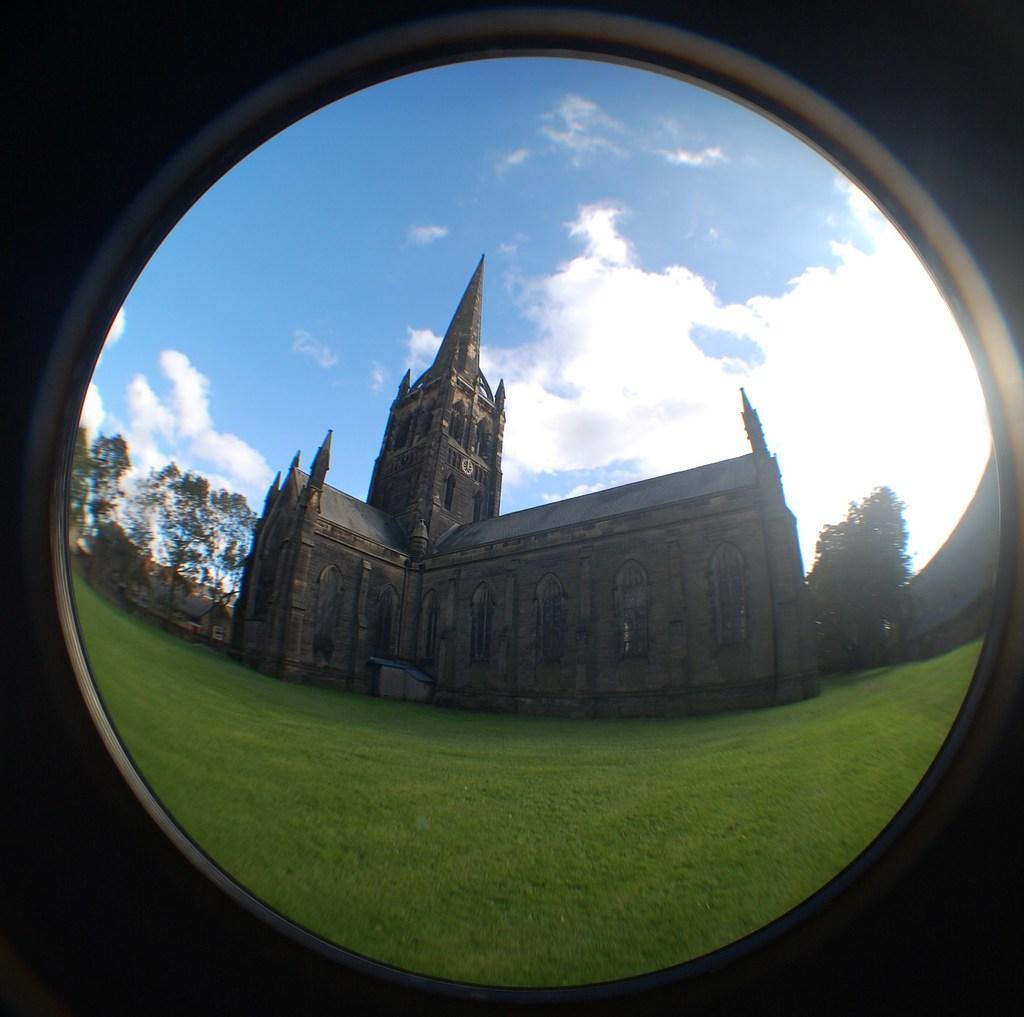Could you give a brief overview of what you see in this image? In this image I can see a church. This looks like a old architecture building. These are the trees. This is the grass. I can see clouds in the sky. 